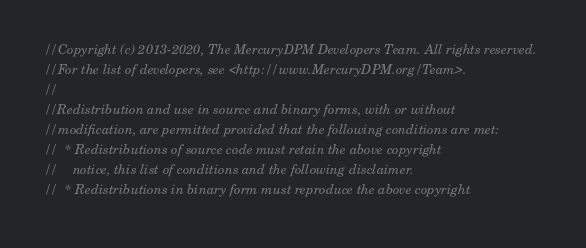Convert code to text. <code><loc_0><loc_0><loc_500><loc_500><_C++_>//Copyright (c) 2013-2020, The MercuryDPM Developers Team. All rights reserved.
//For the list of developers, see <http://www.MercuryDPM.org/Team>.
//
//Redistribution and use in source and binary forms, with or without
//modification, are permitted provided that the following conditions are met:
//  * Redistributions of source code must retain the above copyright
//    notice, this list of conditions and the following disclaimer.
//  * Redistributions in binary form must reproduce the above copyright</code> 